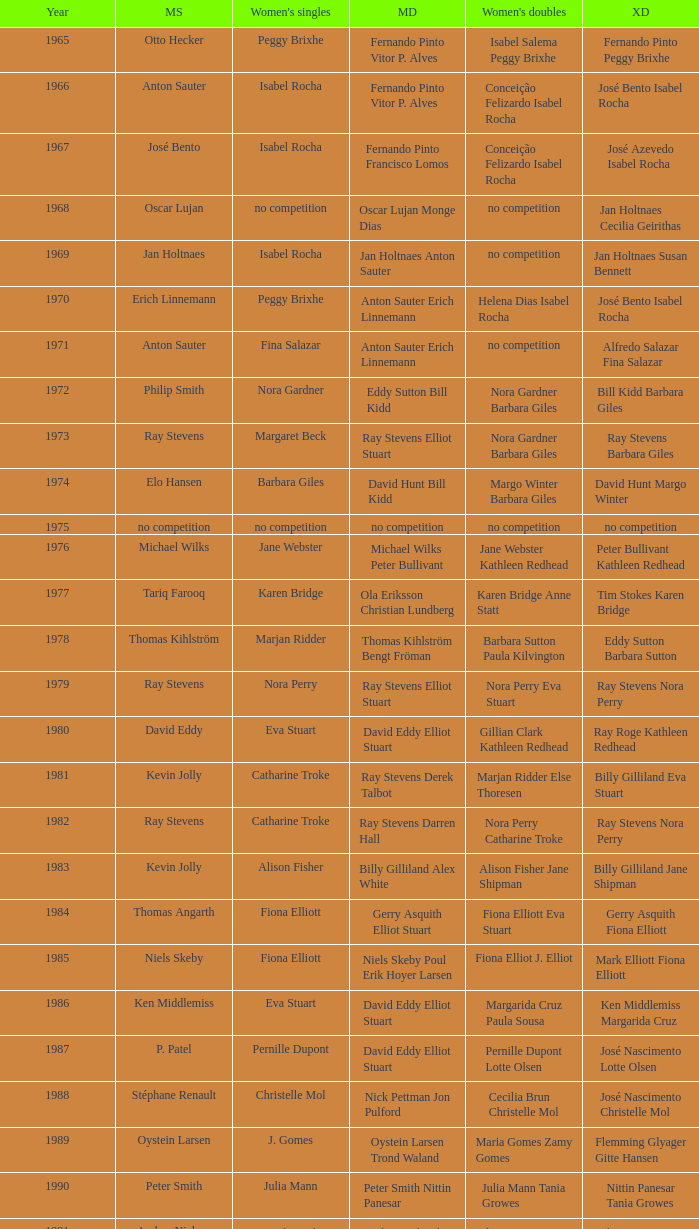Which women's doubles happened after 1987 and a women's single of astrid van der knaap? Elena Denisova Marina Yakusheva. 